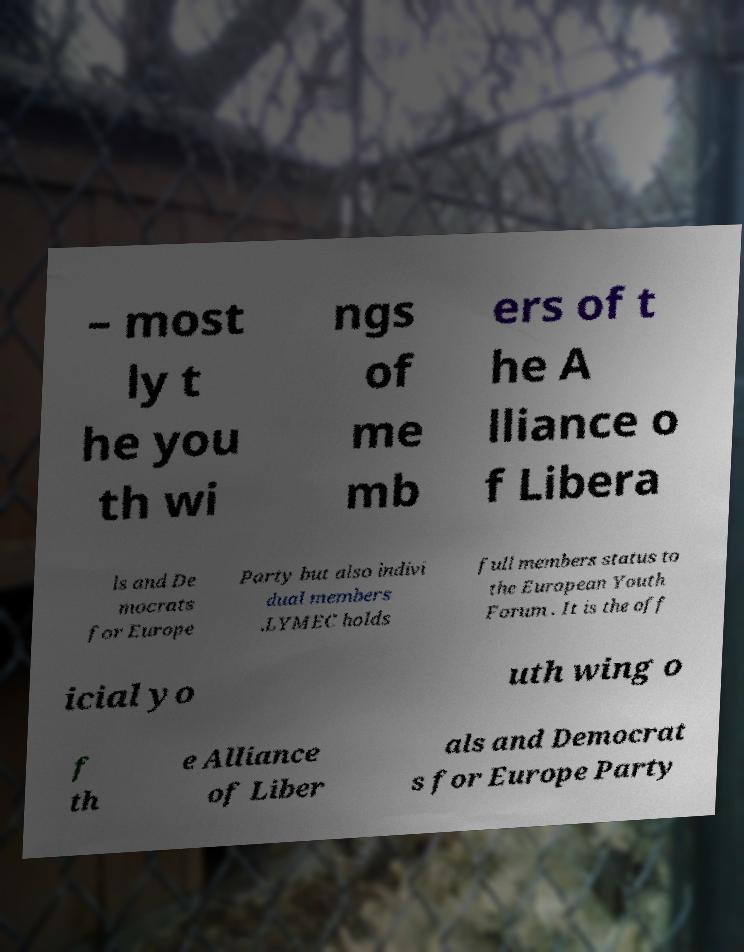Could you extract and type out the text from this image? – most ly t he you th wi ngs of me mb ers of t he A lliance o f Libera ls and De mocrats for Europe Party but also indivi dual members .LYMEC holds full members status to the European Youth Forum . It is the off icial yo uth wing o f th e Alliance of Liber als and Democrat s for Europe Party 